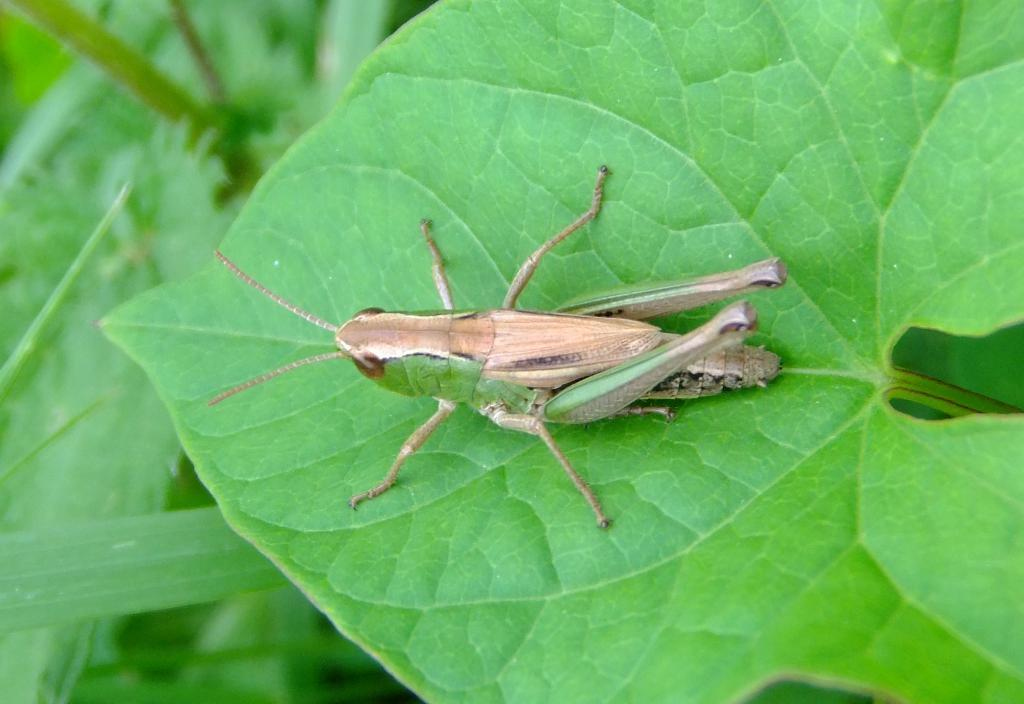What type of natural elements can be seen in the image? There are leaves in the image. What type of small creature can be seen in the image? There is an insect in the image. What type of insurance policy is mentioned in the image? There is no mention of insurance in the image; it features leaves and an insect. What thought process is depicted in the image? There is no thought process depicted in the image; it features leaves and an insect. 